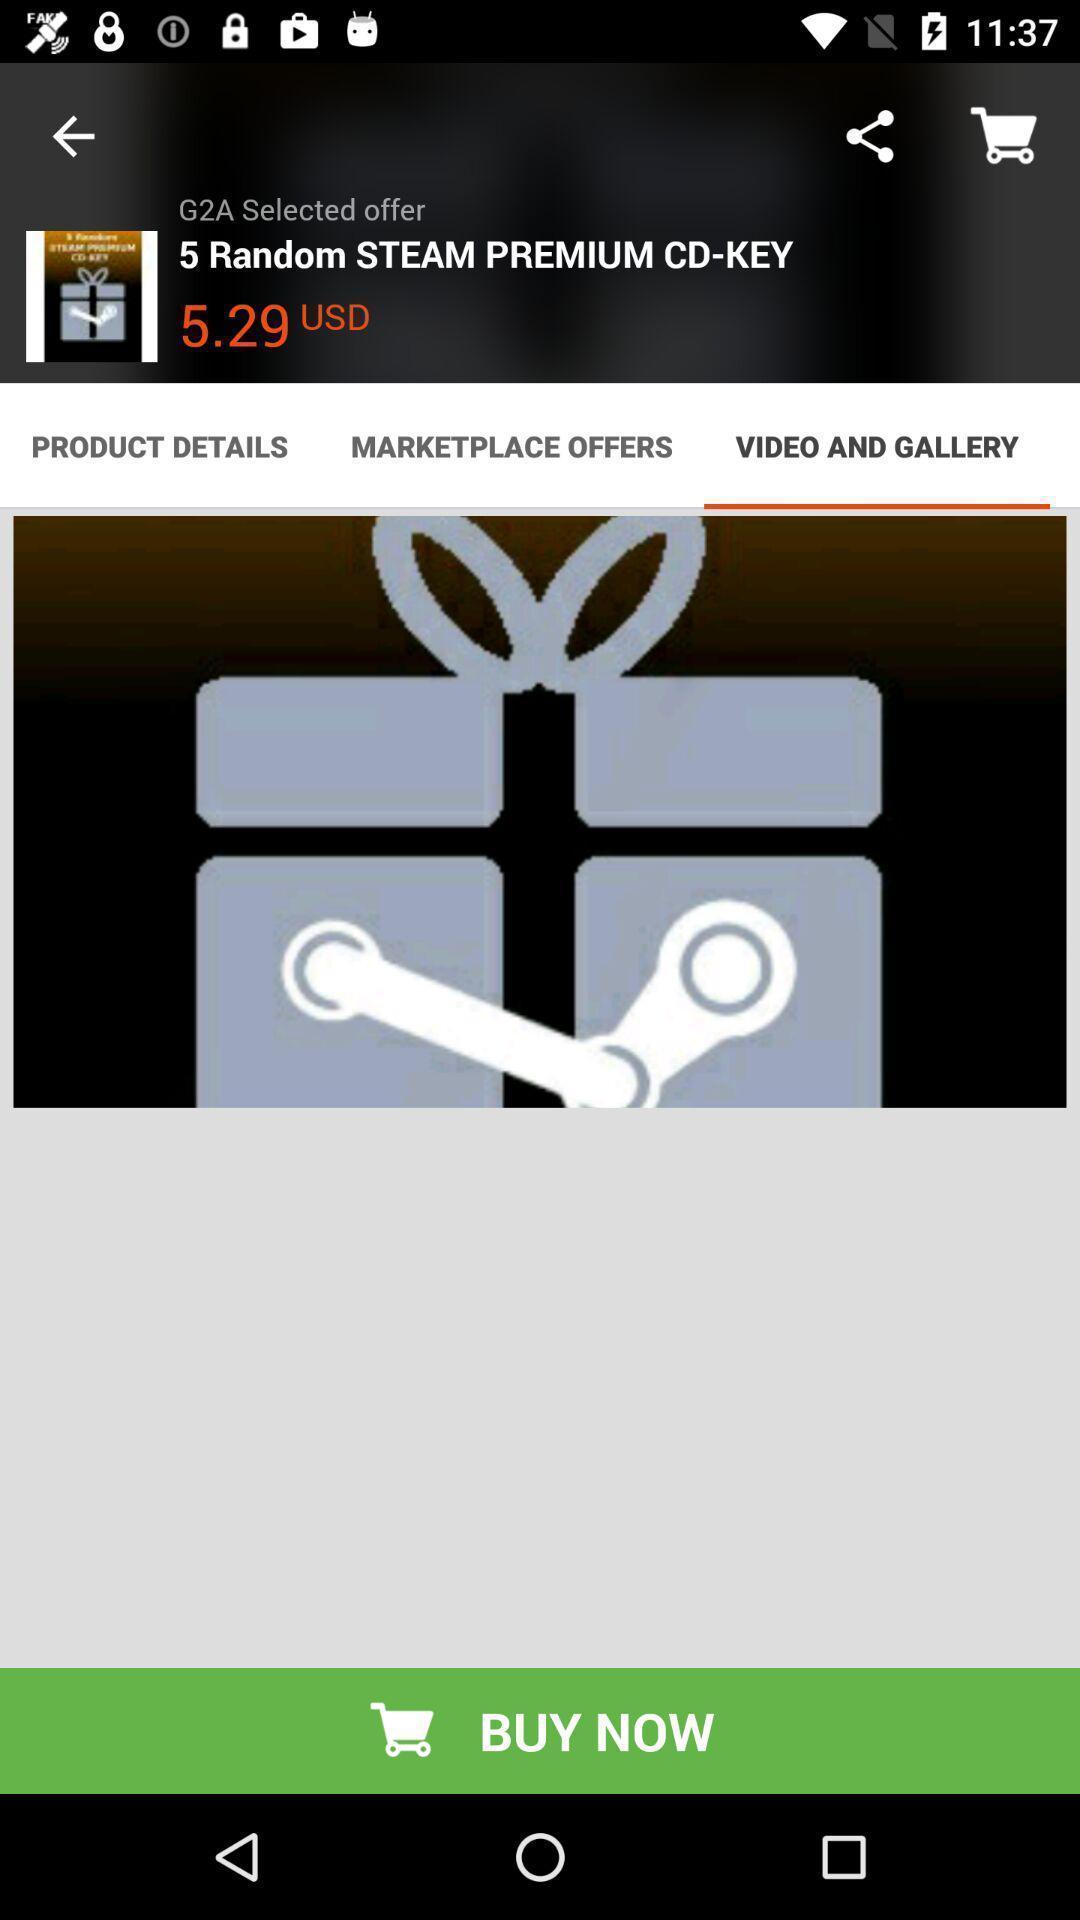Provide a textual representation of this image. Video and gallery page. 